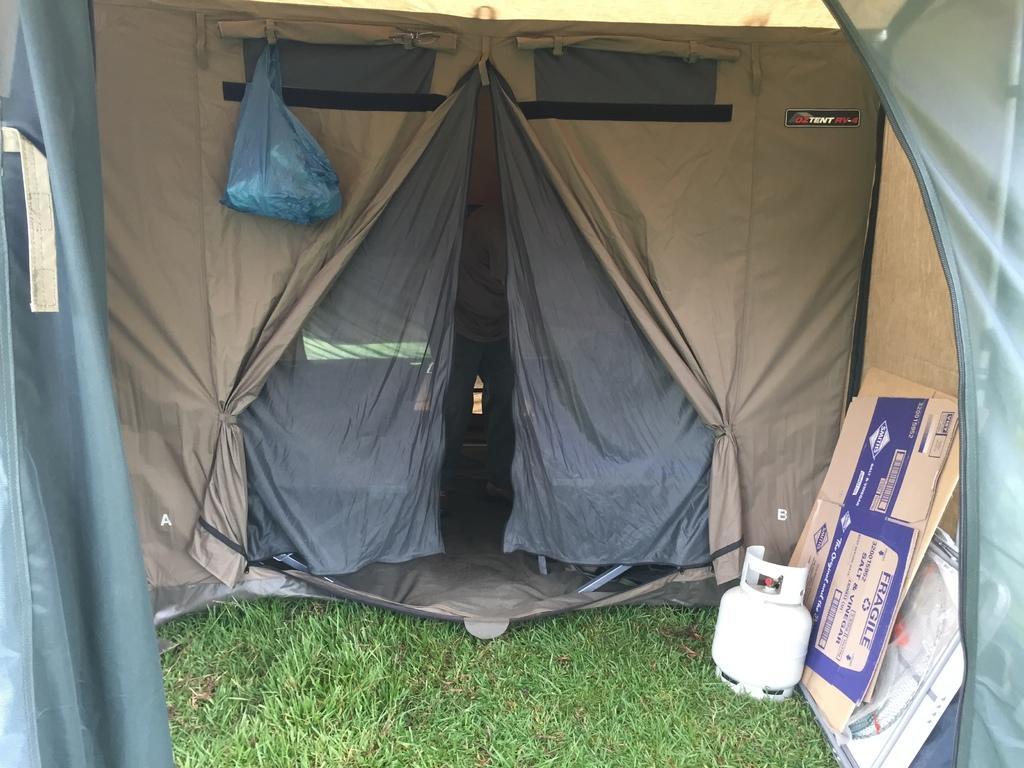How would you summarize this image in a sentence or two? In this image I can see a tent in brown and grey color. I can few few objects, cardboard sheets and green grass. 